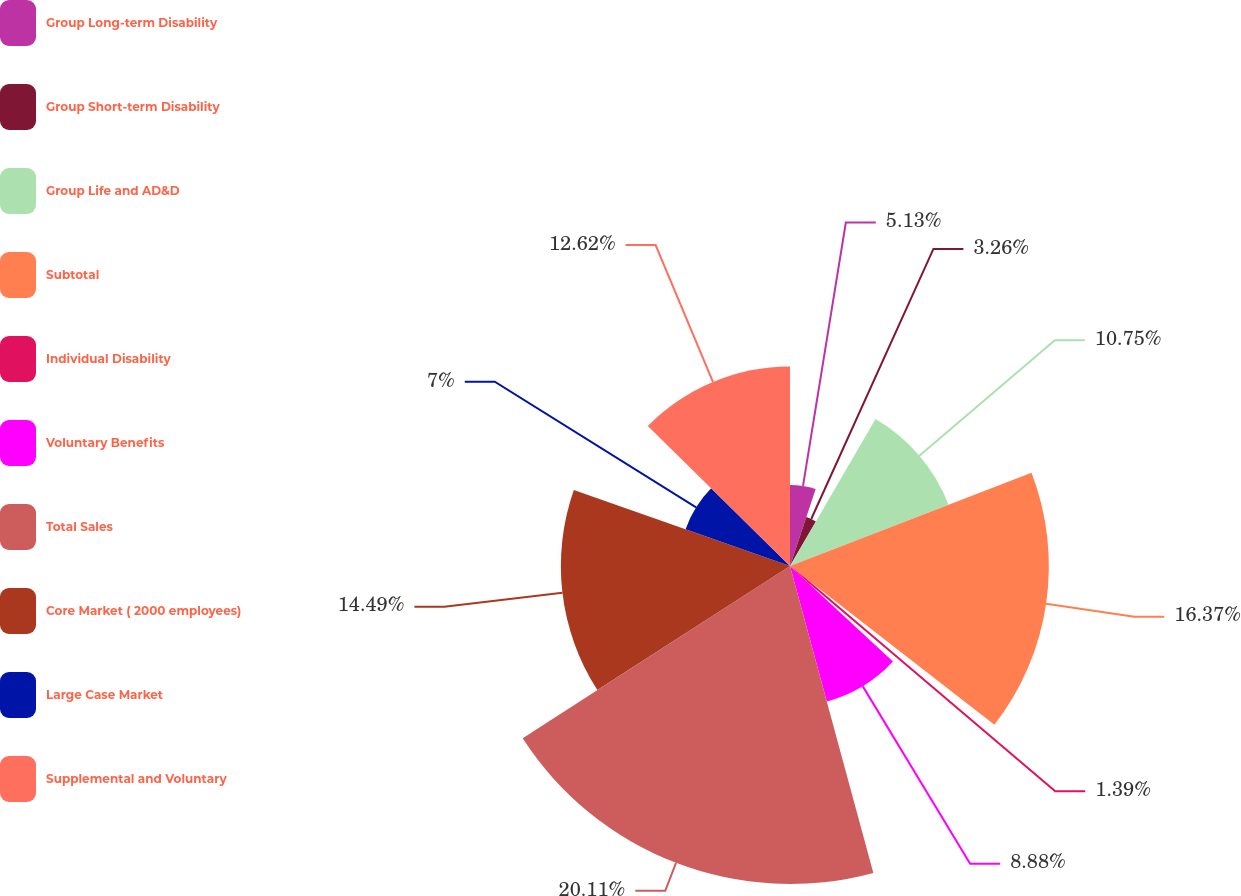Convert chart to OTSL. <chart><loc_0><loc_0><loc_500><loc_500><pie_chart><fcel>Group Long-term Disability<fcel>Group Short-term Disability<fcel>Group Life and AD&D<fcel>Subtotal<fcel>Individual Disability<fcel>Voluntary Benefits<fcel>Total Sales<fcel>Core Market ( 2000 employees)<fcel>Large Case Market<fcel>Supplemental and Voluntary<nl><fcel>5.13%<fcel>3.26%<fcel>10.75%<fcel>16.37%<fcel>1.39%<fcel>8.88%<fcel>20.11%<fcel>14.49%<fcel>7.0%<fcel>12.62%<nl></chart> 